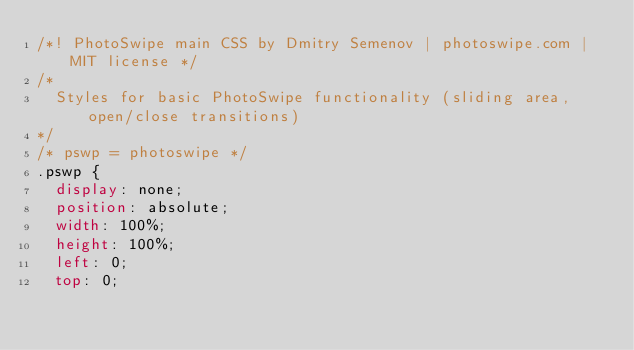<code> <loc_0><loc_0><loc_500><loc_500><_CSS_>/*! PhotoSwipe main CSS by Dmitry Semenov | photoswipe.com | MIT license */
/*
	Styles for basic PhotoSwipe functionality (sliding area, open/close transitions)
*/
/* pswp = photoswipe */
.pswp {
	display: none;
	position: absolute;
	width: 100%;
	height: 100%;
	left: 0;
	top: 0;</code> 